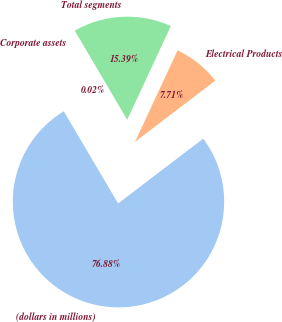<chart> <loc_0><loc_0><loc_500><loc_500><pie_chart><fcel>(dollars in millions)<fcel>Electrical Products<fcel>Total segments<fcel>Corporate assets<nl><fcel>76.88%<fcel>7.71%<fcel>15.39%<fcel>0.02%<nl></chart> 